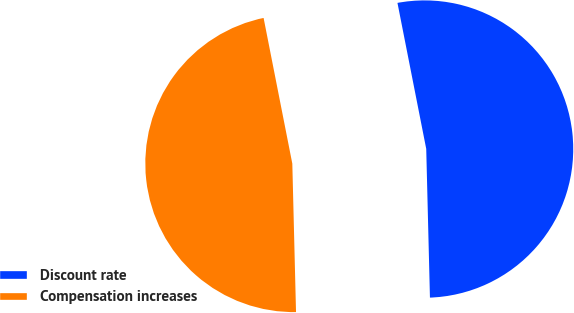<chart> <loc_0><loc_0><loc_500><loc_500><pie_chart><fcel>Discount rate<fcel>Compensation increases<nl><fcel>52.7%<fcel>47.3%<nl></chart> 